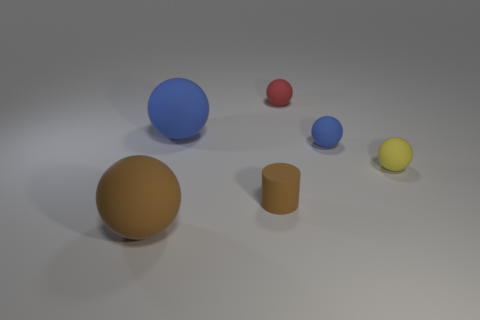Add 1 big blue rubber cubes. How many objects exist? 7 Subtract all blue balls. How many balls are left? 3 Subtract all cylinders. How many objects are left? 5 Subtract all red spheres. How many spheres are left? 4 Subtract all cyan balls. Subtract all cyan cylinders. How many balls are left? 5 Subtract all purple cylinders. How many gray spheres are left? 0 Subtract all yellow metal objects. Subtract all tiny objects. How many objects are left? 2 Add 3 balls. How many balls are left? 8 Add 5 tiny blue spheres. How many tiny blue spheres exist? 6 Subtract 0 red cylinders. How many objects are left? 6 